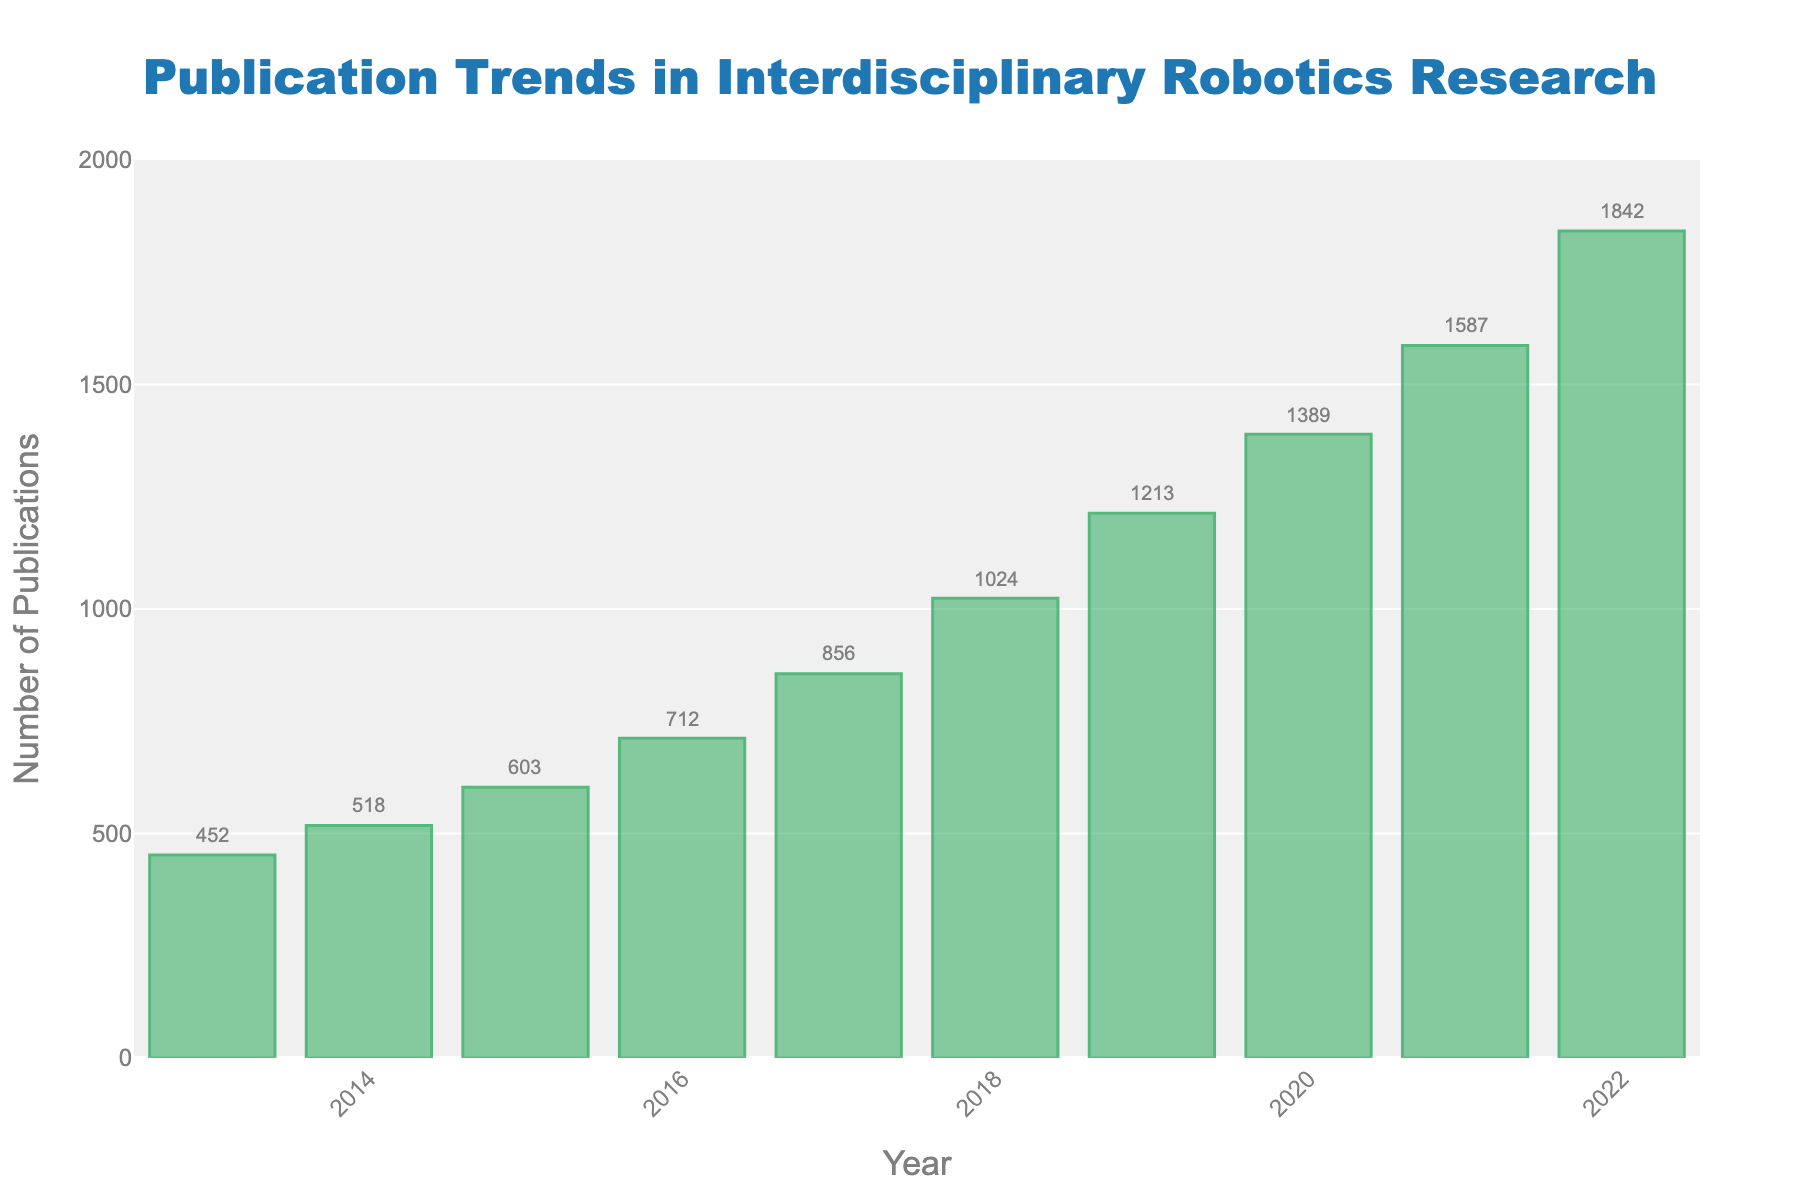What is the total number of publications from 2013 to 2017? Sum the number of publications for each year from 2013 to 2017: 452 (2013) + 518 (2014) + 603 (2015) + 712 (2016) + 856 (2017) = 3141
Answer: 3141 What is the difference in the number of publications between 2022 and 2013? The number of publications in 2022 is 1842, and in 2013 it is 452. Calculate the difference: 1842 - 452 = 1390
Answer: 1390 Which year had the highest number of publications, and what was that number? Identify the tallest bar in the bar chart, which represents the year 2022 with 1842 publications
Answer: 2022, 1842 How did the number of publications change from 2019 to 2020? Compare the bar heights for 2019 and 2020: 1389 (2020) - 1213 (2019) = 176 publications increase
Answer: Increased by 176 What is the average annual number of publications for the entire decade shown? Sum the number of publications for all years and divide by the number of years: (452 + 518 + 603 + 712 + 856 + 1024 + 1213 + 1389 + 1587 + 1842) / 10 = 10195 / 10 = 1019.5
Answer: 1019.5 Between which consecutive years was the largest increase in publications observed? Calculate the increase for each consecutive year pair and identify the largest one:
2014 - 2013: 518 - 452 = 66
2015 - 2014: 603 - 518 = 85
2016 - 2015: 712 - 603 = 109
2017 - 2016: 856 - 712 = 144
2018 - 2017: 1024 - 856 = 168
2019 - 2018: 1213 - 1024 = 189
2020 - 2019: 1389 - 1213 = 176
2021 - 2020: 1587 - 1389 = 198
2022 - 2021: 1842 - 1587 = 255
The largest increase was from 2021 to 2022 (255)
Answer: 2021 to 2022 What proportion of the total publications up to 2022 were made in the last 3 years (2020-2022)? Sum the publications from 2020 to 2022 and divide by the total number of publications then multiply by 100: 
(1389 + 1587 + 1842) / 10195 * 100 = 4818 / 10195 * 100 ≈ 47.25%
Answer: 47.25% How does the number of publications in 2016 compare to 2014? Look at the bar heights for 2016 (712) and 2014 (518), and subtract 518 from 712: 712 - 518 = 194 more publications in 2016
Answer: 194 more What's the percentage increase in publications from 2018 to 2019? Calculate the difference and then the percentage increase: 
(1213 - 1024) / 1024 * 100 = 189 / 1024 * 100 ≈ 18.46%
Answer: 18.46% Is the publication trend generally increasing, decreasing, or stable over the decade? Observe the general progression of the bar heights from 2013 to 2022; they show an overall upward trend
Answer: Increasing 